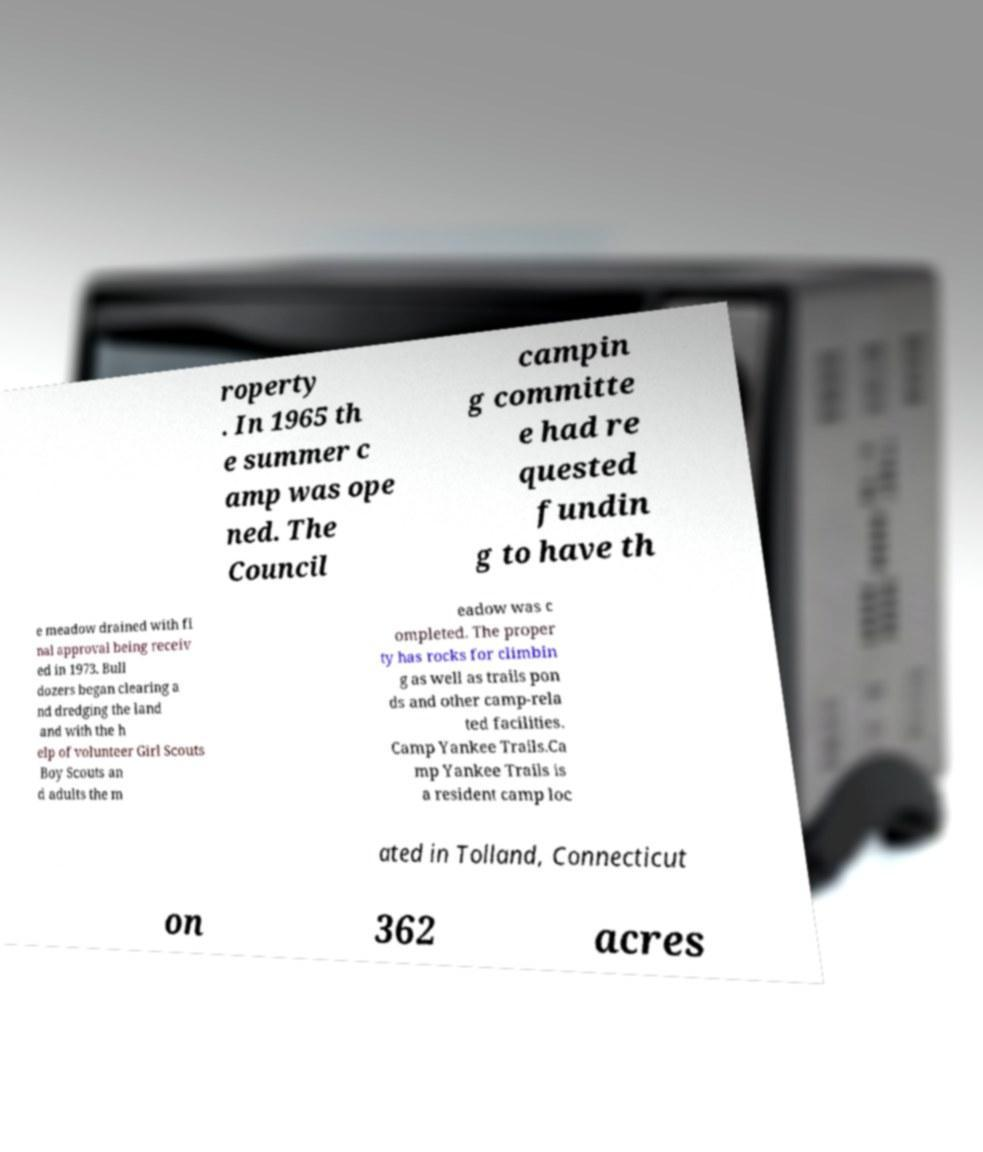Can you accurately transcribe the text from the provided image for me? roperty . In 1965 th e summer c amp was ope ned. The Council campin g committe e had re quested fundin g to have th e meadow drained with fi nal approval being receiv ed in 1973. Bull dozers began clearing a nd dredging the land and with the h elp of volunteer Girl Scouts Boy Scouts an d adults the m eadow was c ompleted. The proper ty has rocks for climbin g as well as trails pon ds and other camp-rela ted facilities. Camp Yankee Trails.Ca mp Yankee Trails is a resident camp loc ated in Tolland, Connecticut on 362 acres 